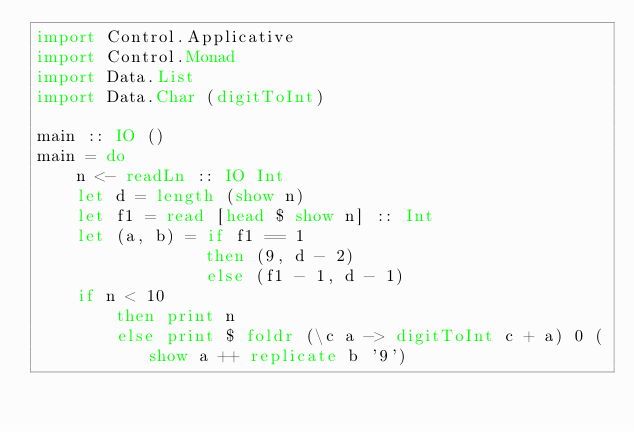<code> <loc_0><loc_0><loc_500><loc_500><_Haskell_>import Control.Applicative
import Control.Monad
import Data.List
import Data.Char (digitToInt)

main :: IO ()
main = do
    n <- readLn :: IO Int
    let d = length (show n)
    let f1 = read [head $ show n] :: Int
    let (a, b) = if f1 == 1
                 then (9, d - 2)
                 else (f1 - 1, d - 1)
    if n < 10
        then print n
        else print $ foldr (\c a -> digitToInt c + a) 0 (show a ++ replicate b '9')</code> 